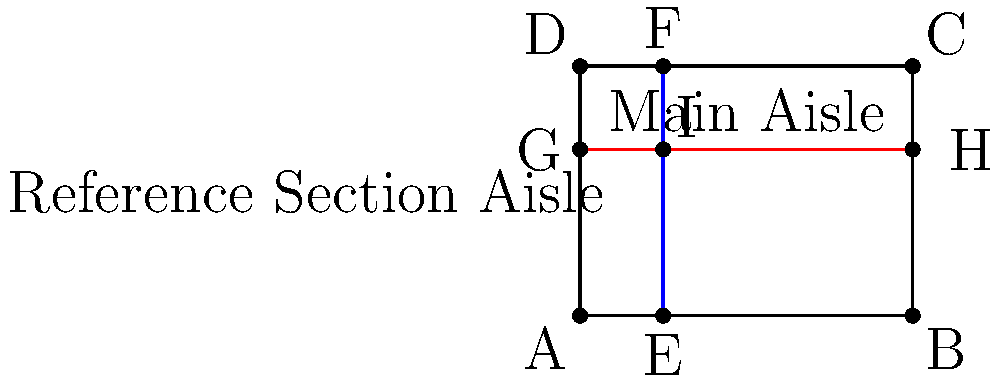In the library floor plan shown above, the main aisle (red line) runs horizontally from point G to point H, while the reference section aisle (blue line) runs vertically from point E to point F. If the library floor is 8 units wide and 6 units long, and the reference section aisle is located 2 units from the left wall, at what coordinates do these two aisles intersect? To find the intersection point of the two perpendicular aisles, we need to determine their equations and solve them simultaneously. Let's approach this step-by-step:

1. The main aisle (red line):
   - It's a horizontal line, so its equation is of the form $y = k$
   - We can see it's 4 units from the bottom, so its equation is $y = 4$

2. The reference section aisle (blue line):
   - It's a vertical line, so its equation is of the form $x = k$
   - We're told it's 2 units from the left wall, so its equation is $x = 2$

3. The intersection point (I) satisfies both equations simultaneously:
   $x = 2$
   $y = 4$

4. Therefore, the coordinates of the intersection point I are (2, 4).

5. We can verify this visually on the diagram, where we see the aisles intersecting at point I, which appears to be 2 units from the left and 4 units from the bottom of the floor plan.
Answer: (2, 4) 